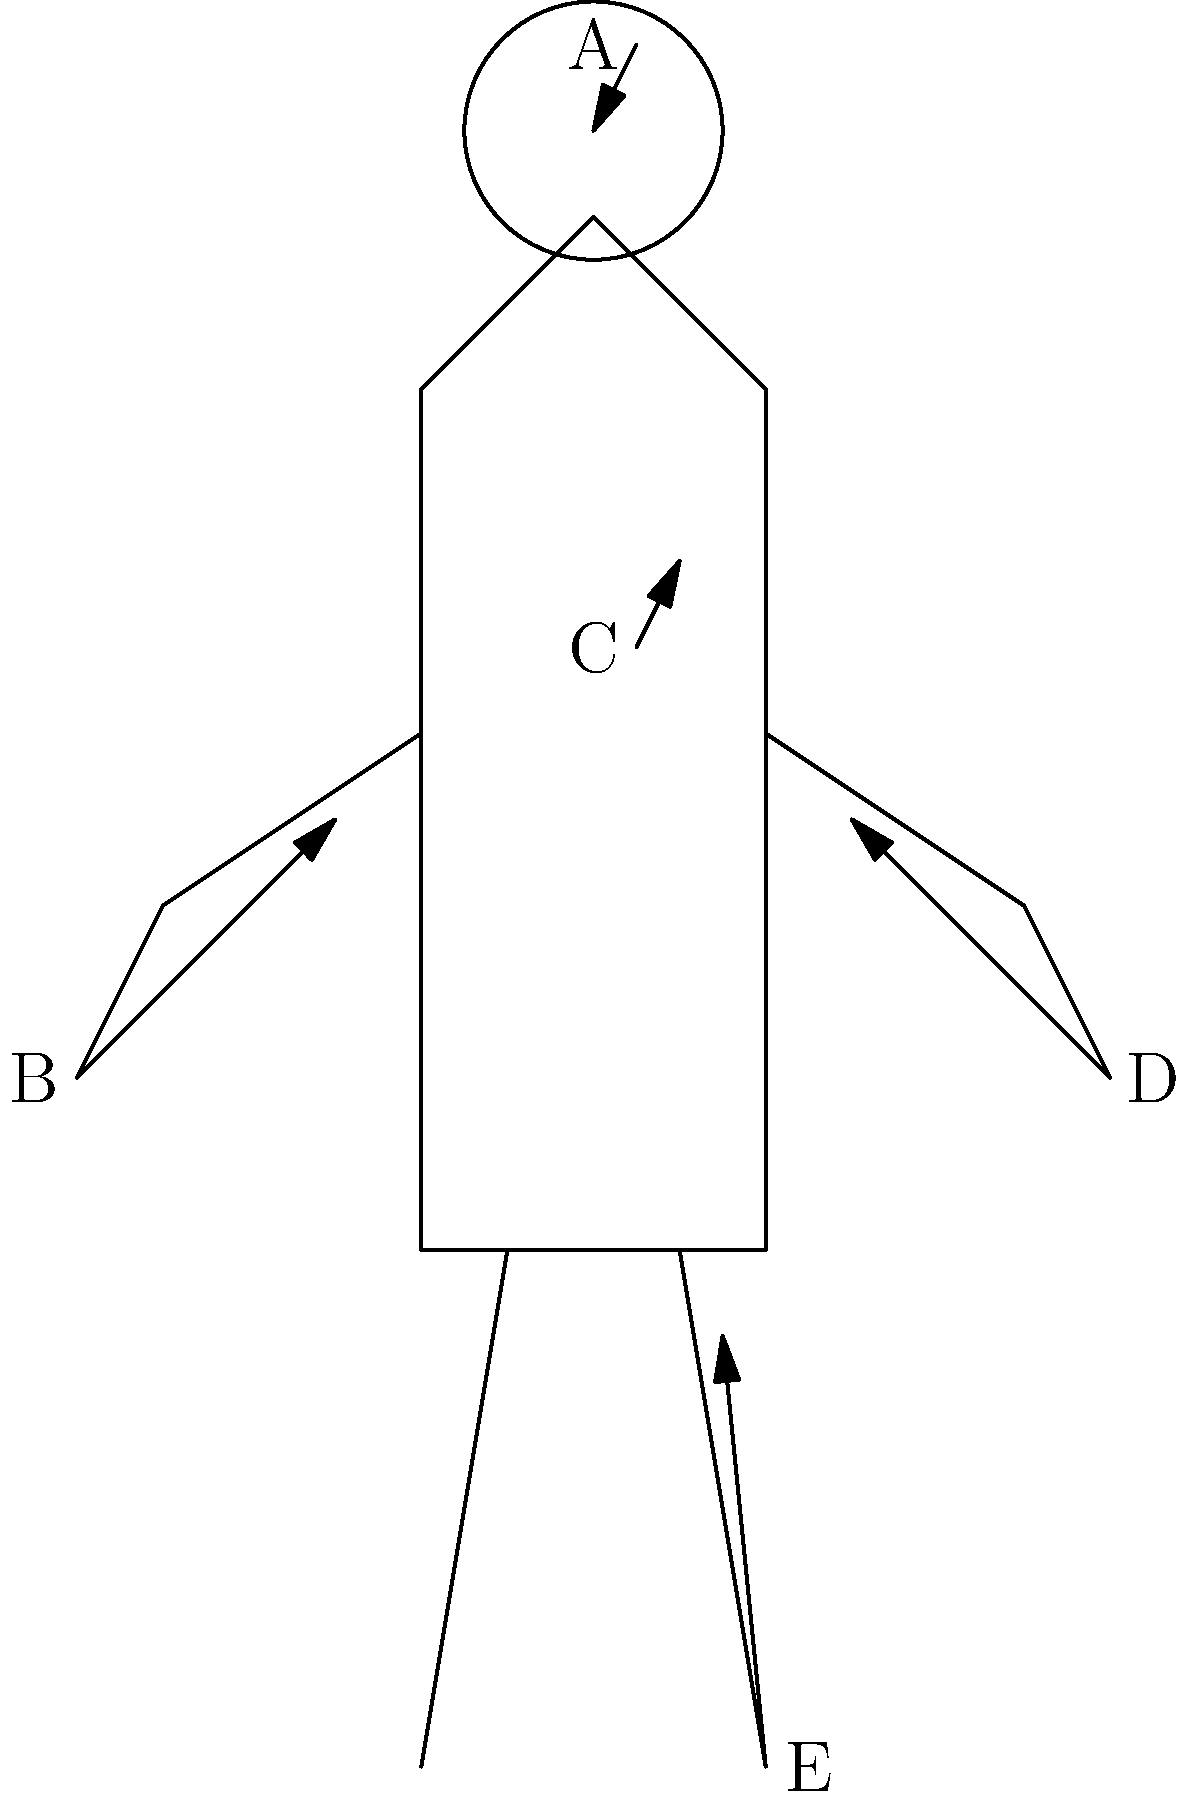Identify the correct linguistic origins for the anatomical terms labeled A through E in the human body diagram. Match each letter with its corresponding root language:

1. Greek
2. Latin
3. Arabic
4. Old English
5. French Let's analyze each labeled part and trace its etymological roots:

A. This points to the head. The anatomical term for the head is "cephalic," which comes from the Greek word "kephalē" meaning head.

B. This indicates the arm. The anatomical term "brachial" referring to the arm comes from the Latin word "brachium" meaning arm.

C. This points to the torso or trunk. The term "thorax" used in anatomy comes directly from the Greek word "thōrax" meaning breastplate or chest.

D. This indicates the hand. The anatomical term "manual" relating to the hand comes from the Latin word "manus" meaning hand.

E. This points to the foot. The anatomical term "pedal" referring to the foot comes from the Latin word "pedalis" meaning of the foot.

In this diagram, we don't see any anatomical terms with Arabic, Old English, or French origins. The majority of anatomical terms come from Greek and Latin due to the historical development of medical terminology.
Answer: A-1, B-2, C-1, D-2, E-2 